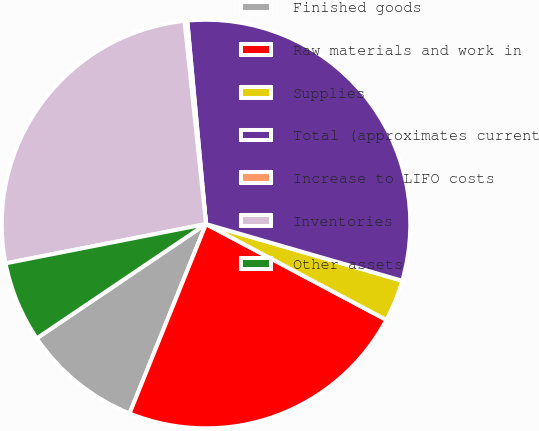<chart> <loc_0><loc_0><loc_500><loc_500><pie_chart><fcel>Finished goods<fcel>Raw materials and work in<fcel>Supplies<fcel>Total (approximates current<fcel>Increase to LIFO costs<fcel>Inventories<fcel>Other assets<nl><fcel>9.44%<fcel>23.33%<fcel>3.3%<fcel>30.94%<fcel>0.22%<fcel>26.4%<fcel>6.37%<nl></chart> 